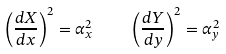<formula> <loc_0><loc_0><loc_500><loc_500>\left ( \frac { d X } { d x } \right ) ^ { 2 } = \alpha _ { x } ^ { 2 } \quad \left ( \frac { d Y } { d y } \right ) ^ { 2 } = \alpha _ { y } ^ { 2 }</formula> 